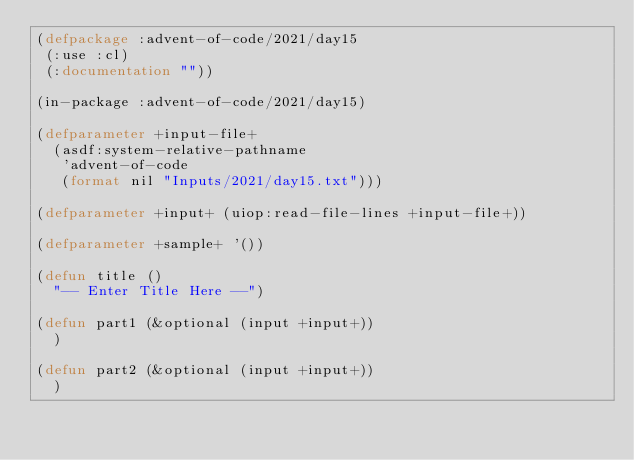Convert code to text. <code><loc_0><loc_0><loc_500><loc_500><_Lisp_>(defpackage :advent-of-code/2021/day15
 (:use :cl)
 (:documentation ""))

(in-package :advent-of-code/2021/day15)

(defparameter +input-file+
  (asdf:system-relative-pathname
   'advent-of-code
   (format nil "Inputs/2021/day15.txt")))

(defparameter +input+ (uiop:read-file-lines +input-file+))

(defparameter +sample+ '())

(defun title ()
  "-- Enter Title Here --")

(defun part1 (&optional (input +input+))
  )

(defun part2 (&optional (input +input+))
  )

</code> 